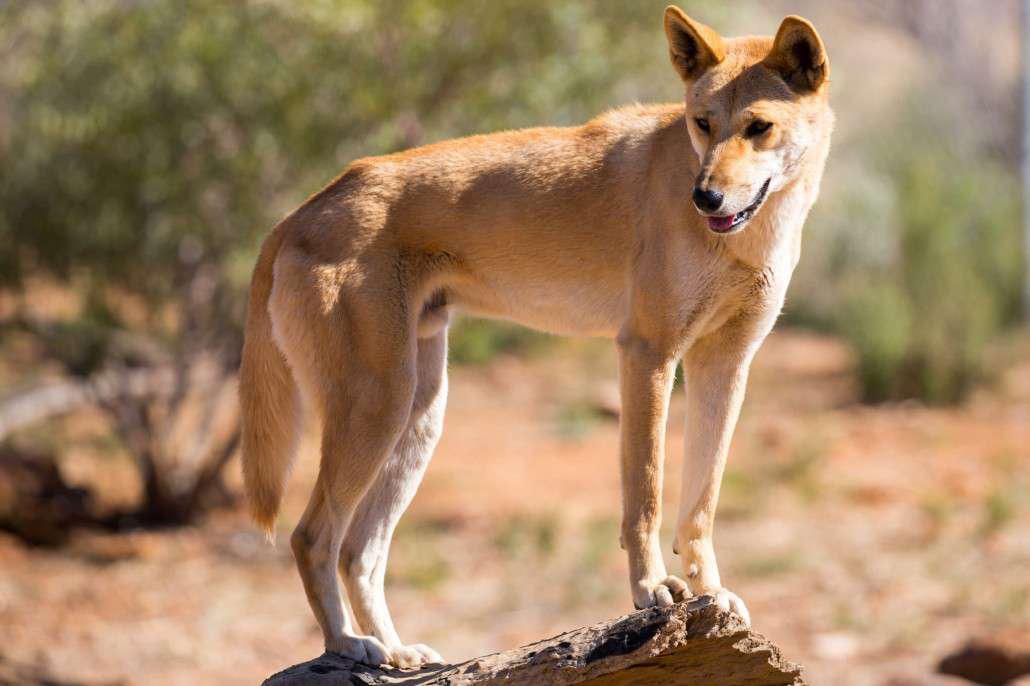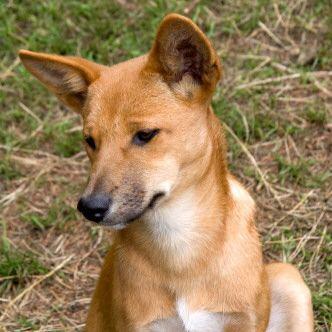The first image is the image on the left, the second image is the image on the right. For the images shown, is this caption "In one image, the animal is standing over grass or other plant life." true? Answer yes or no. Yes. The first image is the image on the left, the second image is the image on the right. Assess this claim about the two images: "There is at least one image there is a single yellow and white dog facing right with their heads turned left.". Correct or not? Answer yes or no. Yes. 